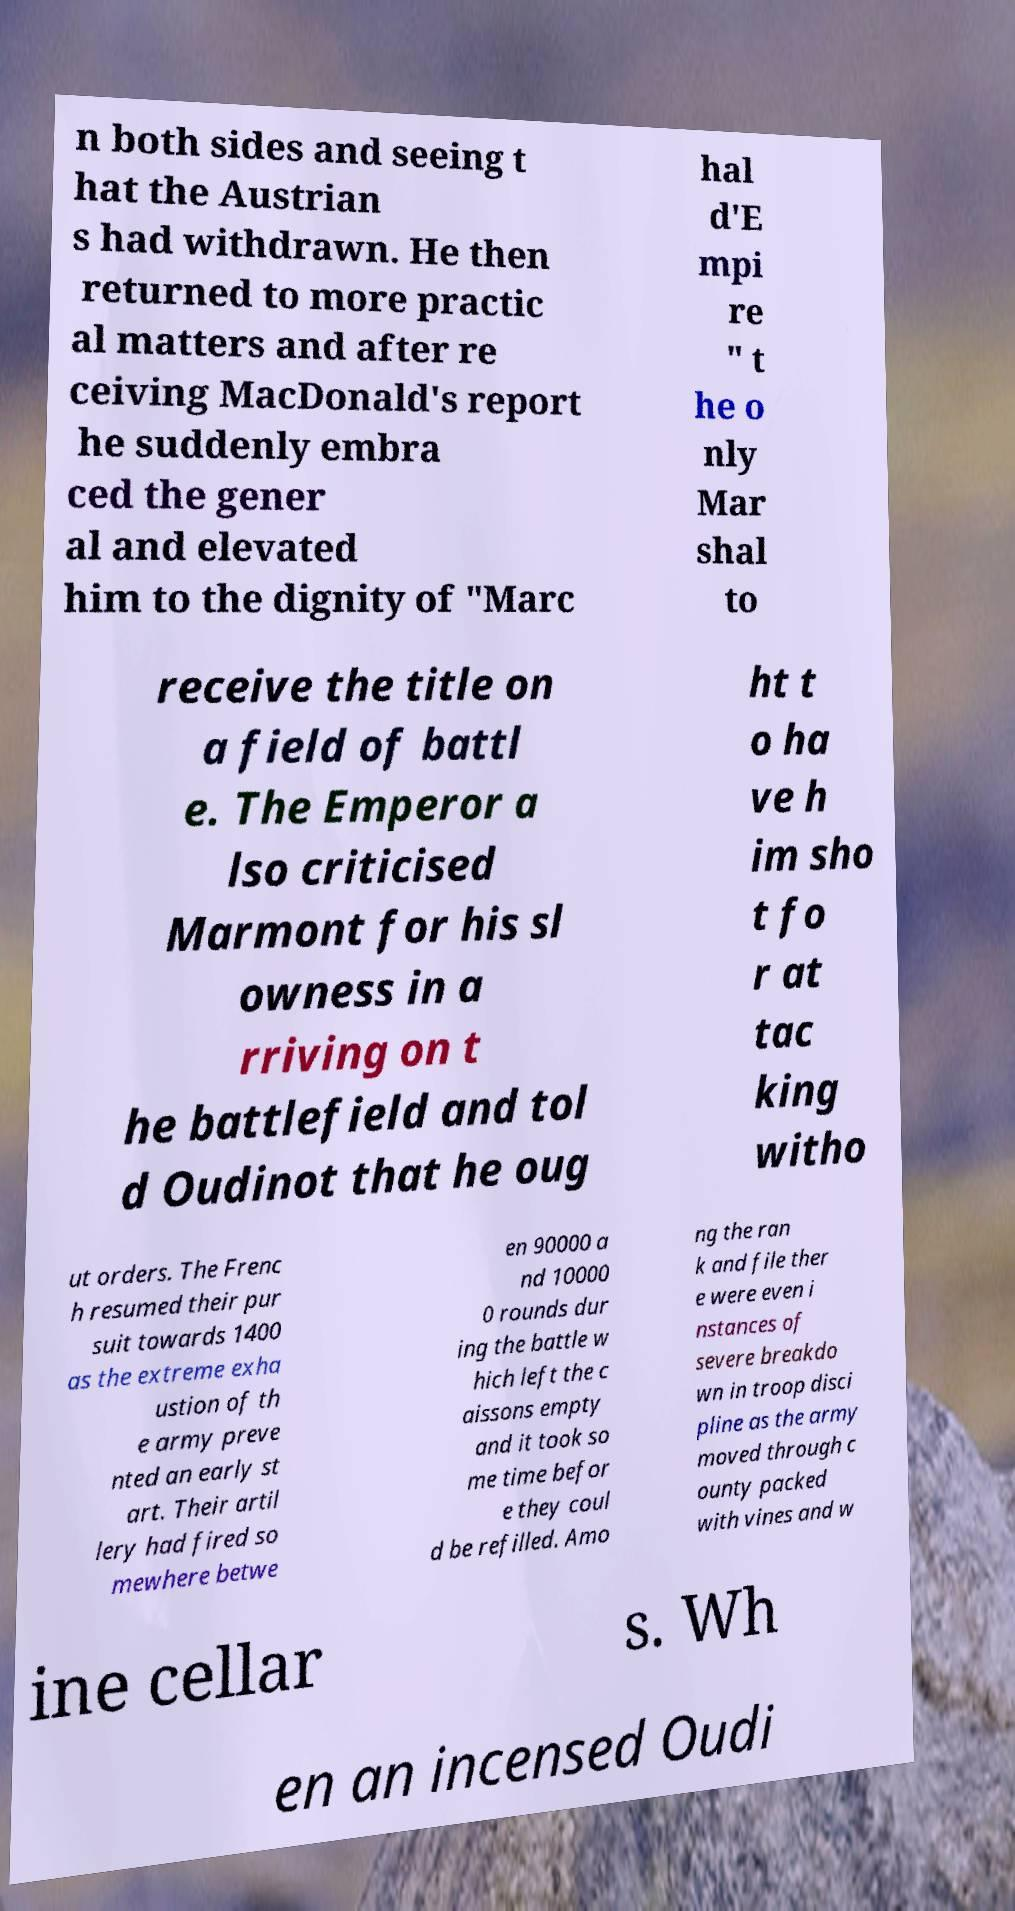Can you read and provide the text displayed in the image?This photo seems to have some interesting text. Can you extract and type it out for me? n both sides and seeing t hat the Austrian s had withdrawn. He then returned to more practic al matters and after re ceiving MacDonald's report he suddenly embra ced the gener al and elevated him to the dignity of "Marc hal d'E mpi re " t he o nly Mar shal to receive the title on a field of battl e. The Emperor a lso criticised Marmont for his sl owness in a rriving on t he battlefield and tol d Oudinot that he oug ht t o ha ve h im sho t fo r at tac king witho ut orders. The Frenc h resumed their pur suit towards 1400 as the extreme exha ustion of th e army preve nted an early st art. Their artil lery had fired so mewhere betwe en 90000 a nd 10000 0 rounds dur ing the battle w hich left the c aissons empty and it took so me time befor e they coul d be refilled. Amo ng the ran k and file ther e were even i nstances of severe breakdo wn in troop disci pline as the army moved through c ounty packed with vines and w ine cellar s. Wh en an incensed Oudi 